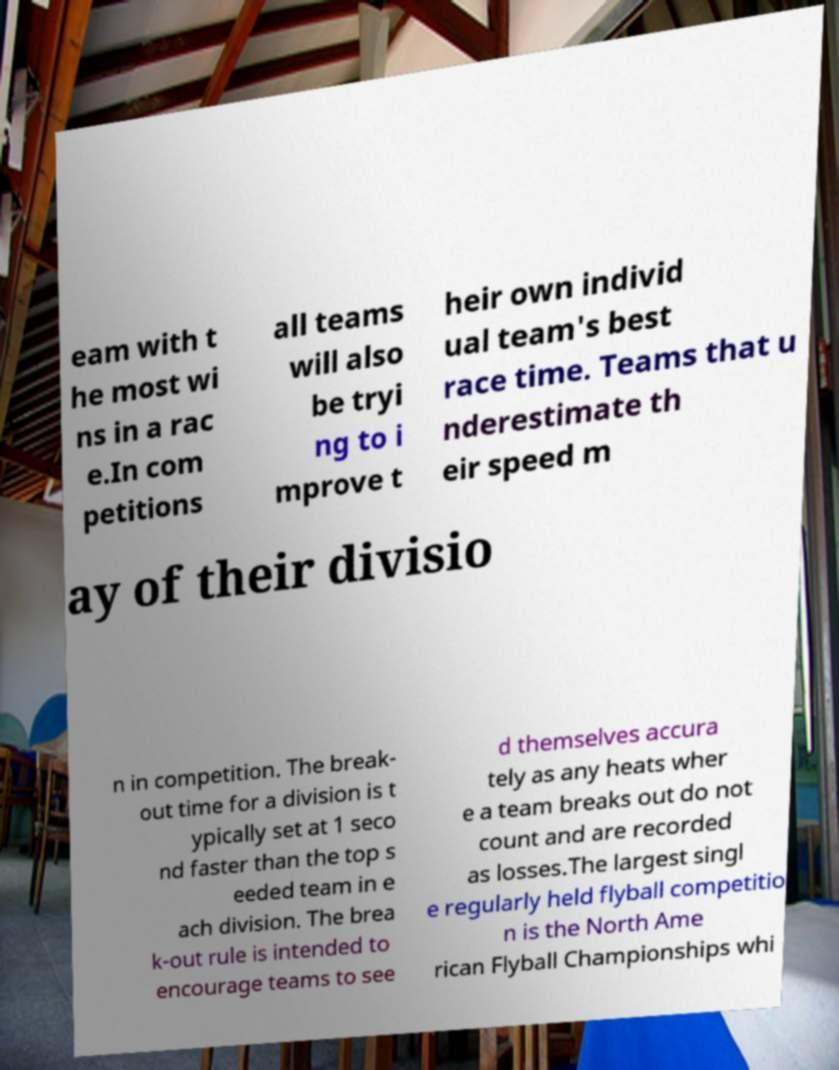Can you read and provide the text displayed in the image?This photo seems to have some interesting text. Can you extract and type it out for me? eam with t he most wi ns in a rac e.In com petitions all teams will also be tryi ng to i mprove t heir own individ ual team's best race time. Teams that u nderestimate th eir speed m ay of their divisio n in competition. The break- out time for a division is t ypically set at 1 seco nd faster than the top s eeded team in e ach division. The brea k-out rule is intended to encourage teams to see d themselves accura tely as any heats wher e a team breaks out do not count and are recorded as losses.The largest singl e regularly held flyball competitio n is the North Ame rican Flyball Championships whi 